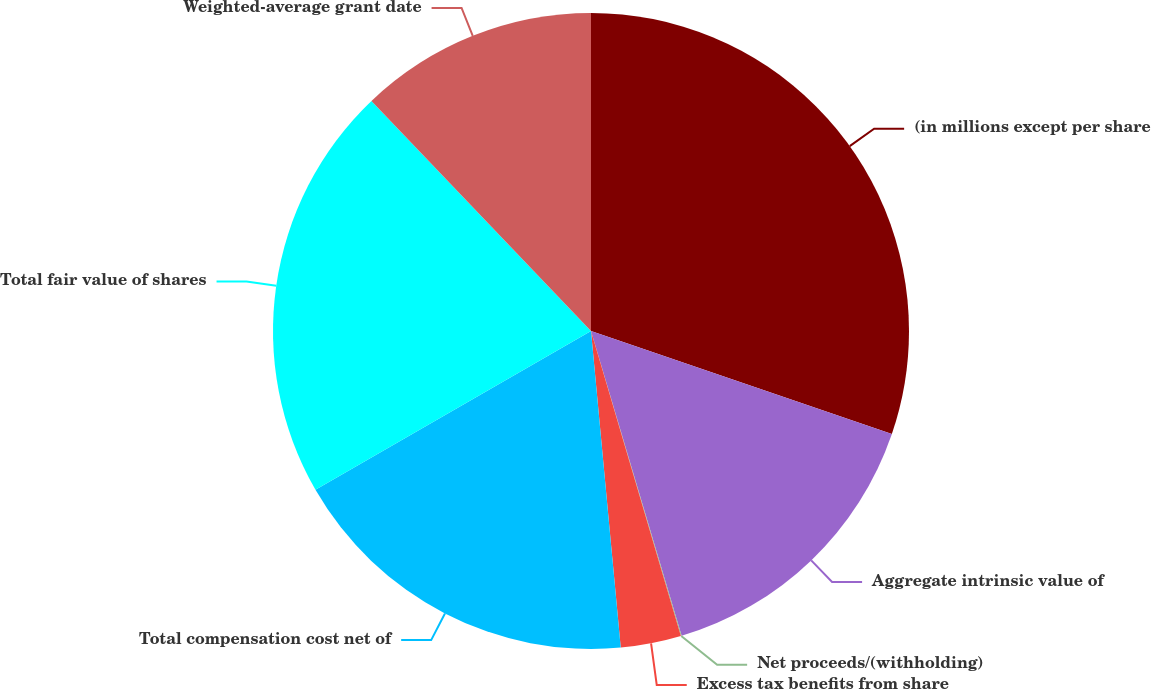Convert chart to OTSL. <chart><loc_0><loc_0><loc_500><loc_500><pie_chart><fcel>(in millions except per share<fcel>Aggregate intrinsic value of<fcel>Net proceeds/(withholding)<fcel>Excess tax benefits from share<fcel>Total compensation cost net of<fcel>Total fair value of shares<fcel>Weighted-average grant date<nl><fcel>30.25%<fcel>15.15%<fcel>0.04%<fcel>3.07%<fcel>18.17%<fcel>21.19%<fcel>12.13%<nl></chart> 